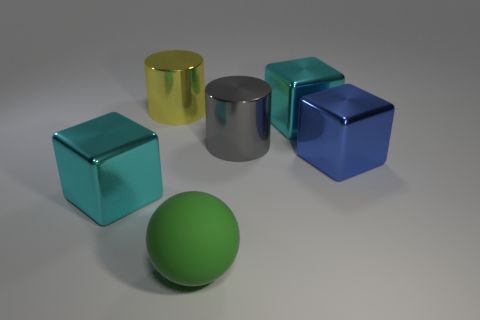There is a big metal cube that is behind the blue object; is its color the same as the cube that is left of the large gray object?
Provide a succinct answer. Yes. Is there a tiny cyan metal cylinder?
Offer a terse response. No. There is a cylinder that is behind the cyan metallic block that is on the right side of the big cyan metallic thing that is in front of the gray metal cylinder; what size is it?
Your answer should be very brief. Large. The blue metal object that is the same size as the green rubber thing is what shape?
Offer a very short reply. Cube. Is there anything else that has the same material as the big green ball?
Provide a succinct answer. No. What number of objects are either yellow cylinders behind the big gray object or large yellow metal cylinders?
Give a very brief answer. 1. Is there a big cyan object in front of the thing in front of the big shiny block in front of the blue metal block?
Provide a succinct answer. No. How many metallic cylinders are there?
Provide a succinct answer. 2. What number of things are either shiny blocks on the left side of the big sphere or big metallic objects on the left side of the large gray shiny thing?
Provide a succinct answer. 2. There is a metallic cylinder that is behind the gray metal thing; does it have the same size as the large green thing?
Give a very brief answer. Yes. 